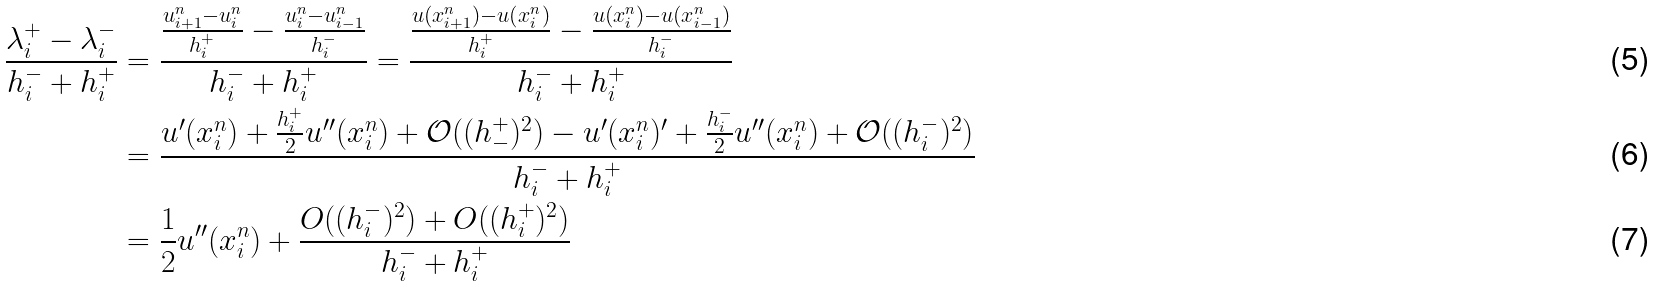Convert formula to latex. <formula><loc_0><loc_0><loc_500><loc_500>\frac { \lambda _ { i } ^ { + } - \lambda _ { i } ^ { - } } { h _ { i } ^ { - } + h _ { i } ^ { + } } & = \frac { \frac { u _ { i + 1 } ^ { n } - u _ { i } ^ { n } } { h _ { i } ^ { + } } - \frac { u _ { i } ^ { n } - u _ { i - 1 } ^ { n } } { h _ { i } ^ { - } } } { h _ { i } ^ { - } + h _ { i } ^ { + } } = \frac { \frac { u ( x _ { i + 1 } ^ { n } ) - u ( x _ { i } ^ { n } ) } { h _ { i } ^ { + } } - \frac { u ( x _ { i } ^ { n } ) - u ( x _ { i - 1 } ^ { n } ) } { h _ { i } ^ { - } } } { h _ { i } ^ { - } + h _ { i } ^ { + } } \\ & = \frac { u ^ { \prime } ( x _ { i } ^ { n } ) + \frac { h _ { i } ^ { + } } { 2 } u ^ { \prime \prime } ( x _ { i } ^ { n } ) + \mathcal { O } ( ( h _ { - } ^ { + } ) ^ { 2 } ) - u ^ { \prime } ( x _ { i } ^ { n } ) ^ { \prime } + \frac { h _ { i } ^ { - } } { 2 } u ^ { \prime \prime } ( x _ { i } ^ { n } ) + \mathcal { O } ( ( h _ { i } ^ { - } ) ^ { 2 } ) } { h _ { i } ^ { - } + h _ { i } ^ { + } } \\ & = \frac { 1 } { 2 } u ^ { \prime \prime } ( x _ { i } ^ { n } ) + \frac { O ( ( h _ { i } ^ { - } ) ^ { 2 } ) + O ( ( h _ { i } ^ { + } ) ^ { 2 } ) } { h _ { i } ^ { - } + h _ { i } ^ { + } }</formula> 